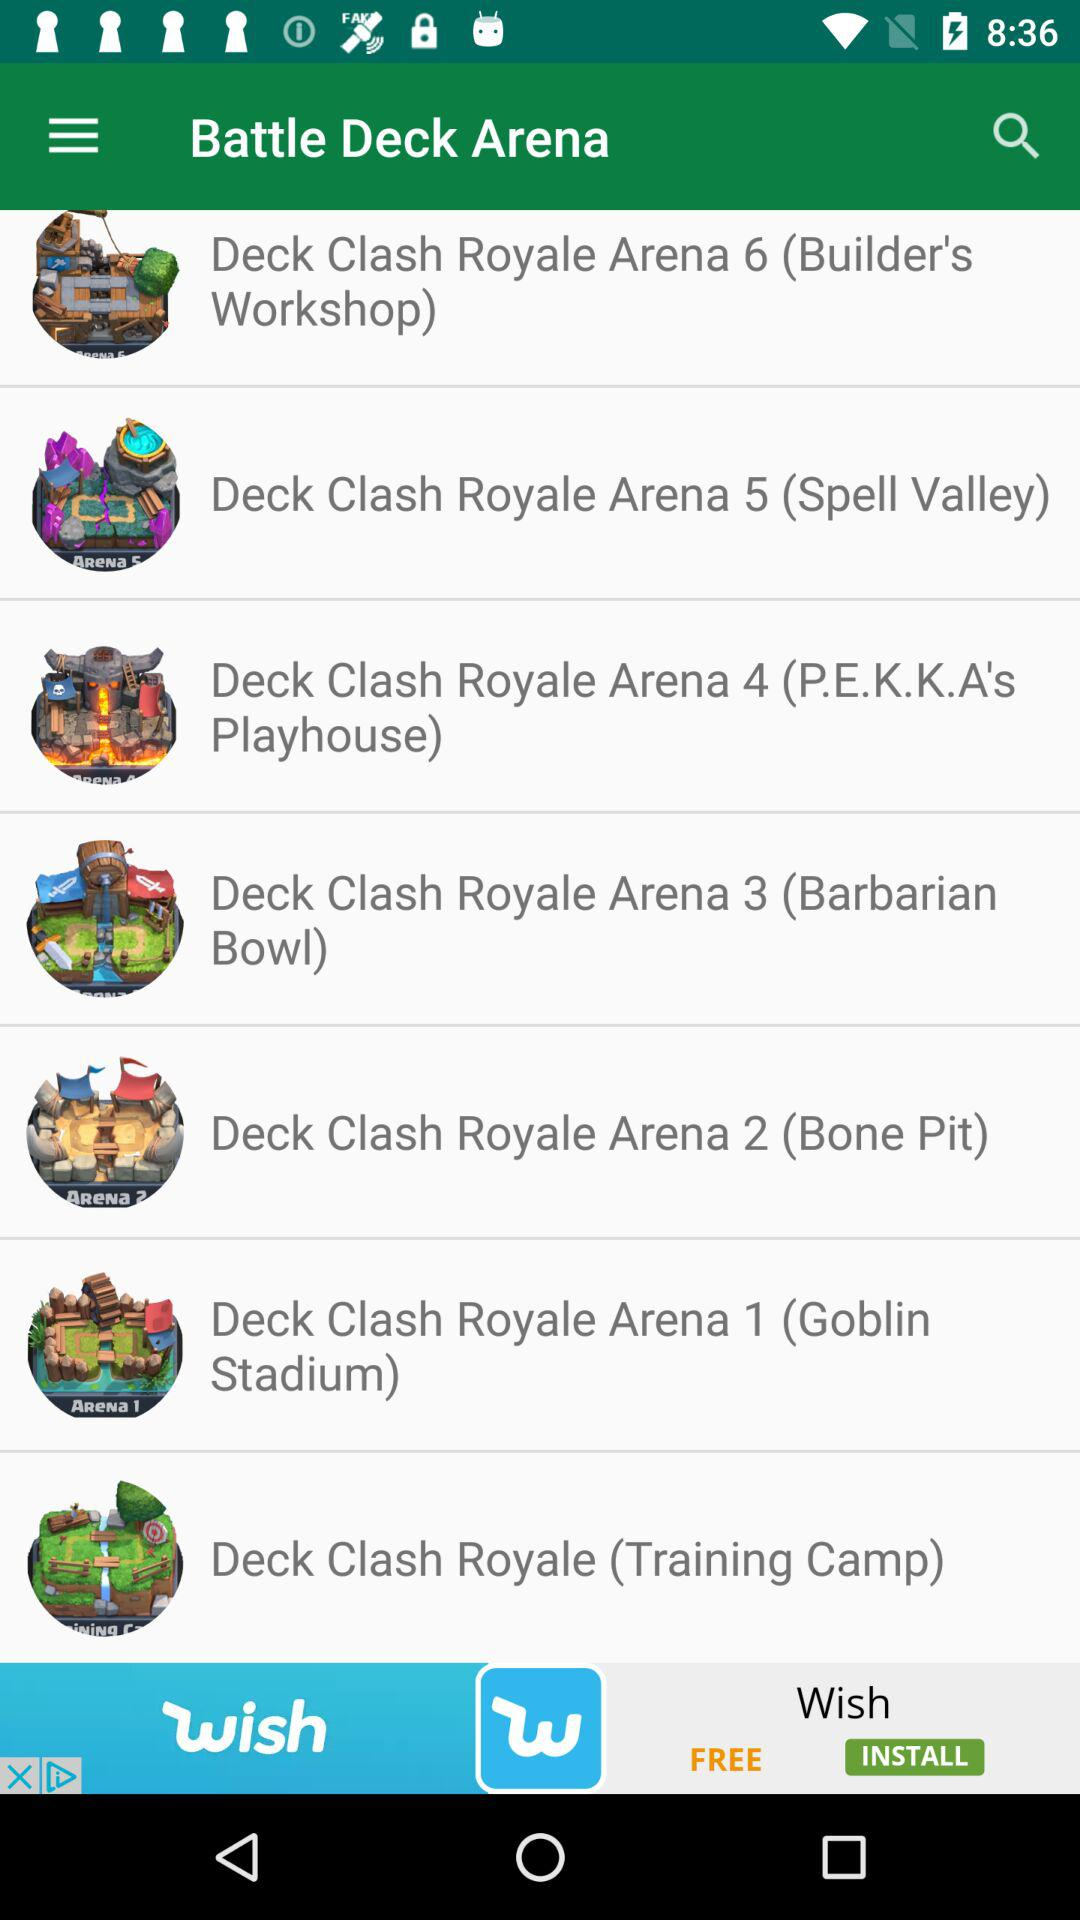What is the name of the application? The name of the application is "Battle Deck Arena". 